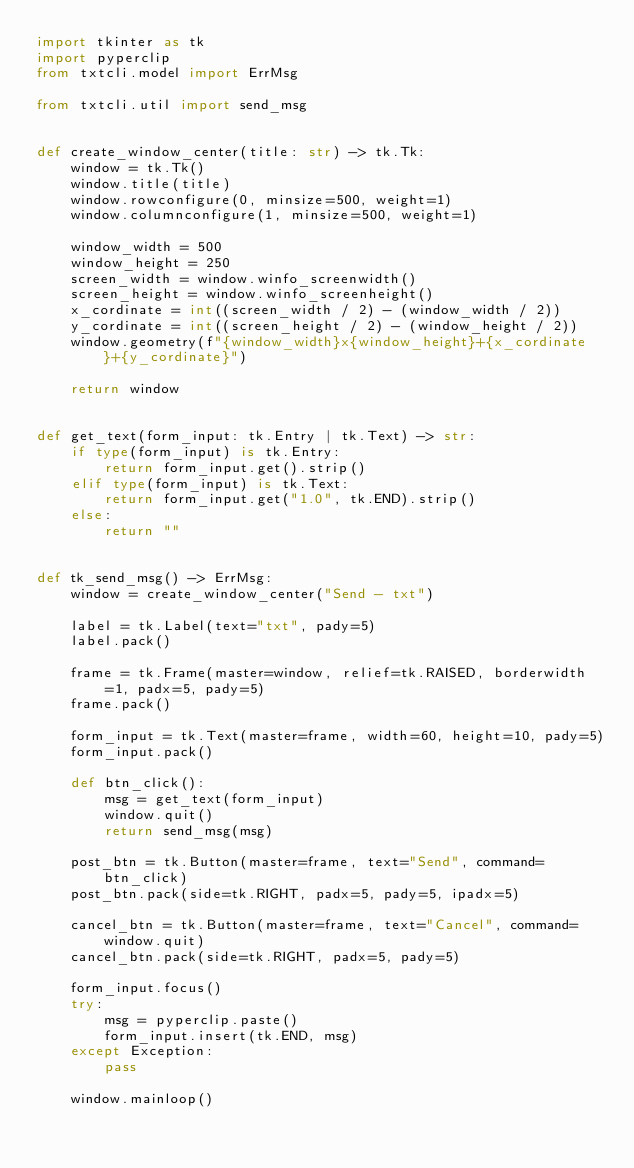<code> <loc_0><loc_0><loc_500><loc_500><_Python_>import tkinter as tk
import pyperclip
from txtcli.model import ErrMsg

from txtcli.util import send_msg


def create_window_center(title: str) -> tk.Tk:
    window = tk.Tk()
    window.title(title)
    window.rowconfigure(0, minsize=500, weight=1)
    window.columnconfigure(1, minsize=500, weight=1)

    window_width = 500
    window_height = 250
    screen_width = window.winfo_screenwidth()
    screen_height = window.winfo_screenheight()
    x_cordinate = int((screen_width / 2) - (window_width / 2))
    y_cordinate = int((screen_height / 2) - (window_height / 2))
    window.geometry(f"{window_width}x{window_height}+{x_cordinate}+{y_cordinate}")

    return window


def get_text(form_input: tk.Entry | tk.Text) -> str:
    if type(form_input) is tk.Entry:
        return form_input.get().strip()
    elif type(form_input) is tk.Text:
        return form_input.get("1.0", tk.END).strip()
    else:
        return ""


def tk_send_msg() -> ErrMsg:
    window = create_window_center("Send - txt")

    label = tk.Label(text="txt", pady=5)
    label.pack()

    frame = tk.Frame(master=window, relief=tk.RAISED, borderwidth=1, padx=5, pady=5)
    frame.pack()

    form_input = tk.Text(master=frame, width=60, height=10, pady=5)
    form_input.pack()

    def btn_click():
        msg = get_text(form_input)
        window.quit()
        return send_msg(msg)

    post_btn = tk.Button(master=frame, text="Send", command=btn_click)
    post_btn.pack(side=tk.RIGHT, padx=5, pady=5, ipadx=5)

    cancel_btn = tk.Button(master=frame, text="Cancel", command=window.quit)
    cancel_btn.pack(side=tk.RIGHT, padx=5, pady=5)

    form_input.focus()
    try:
        msg = pyperclip.paste()
        form_input.insert(tk.END, msg)
    except Exception:
        pass

    window.mainloop()
</code> 